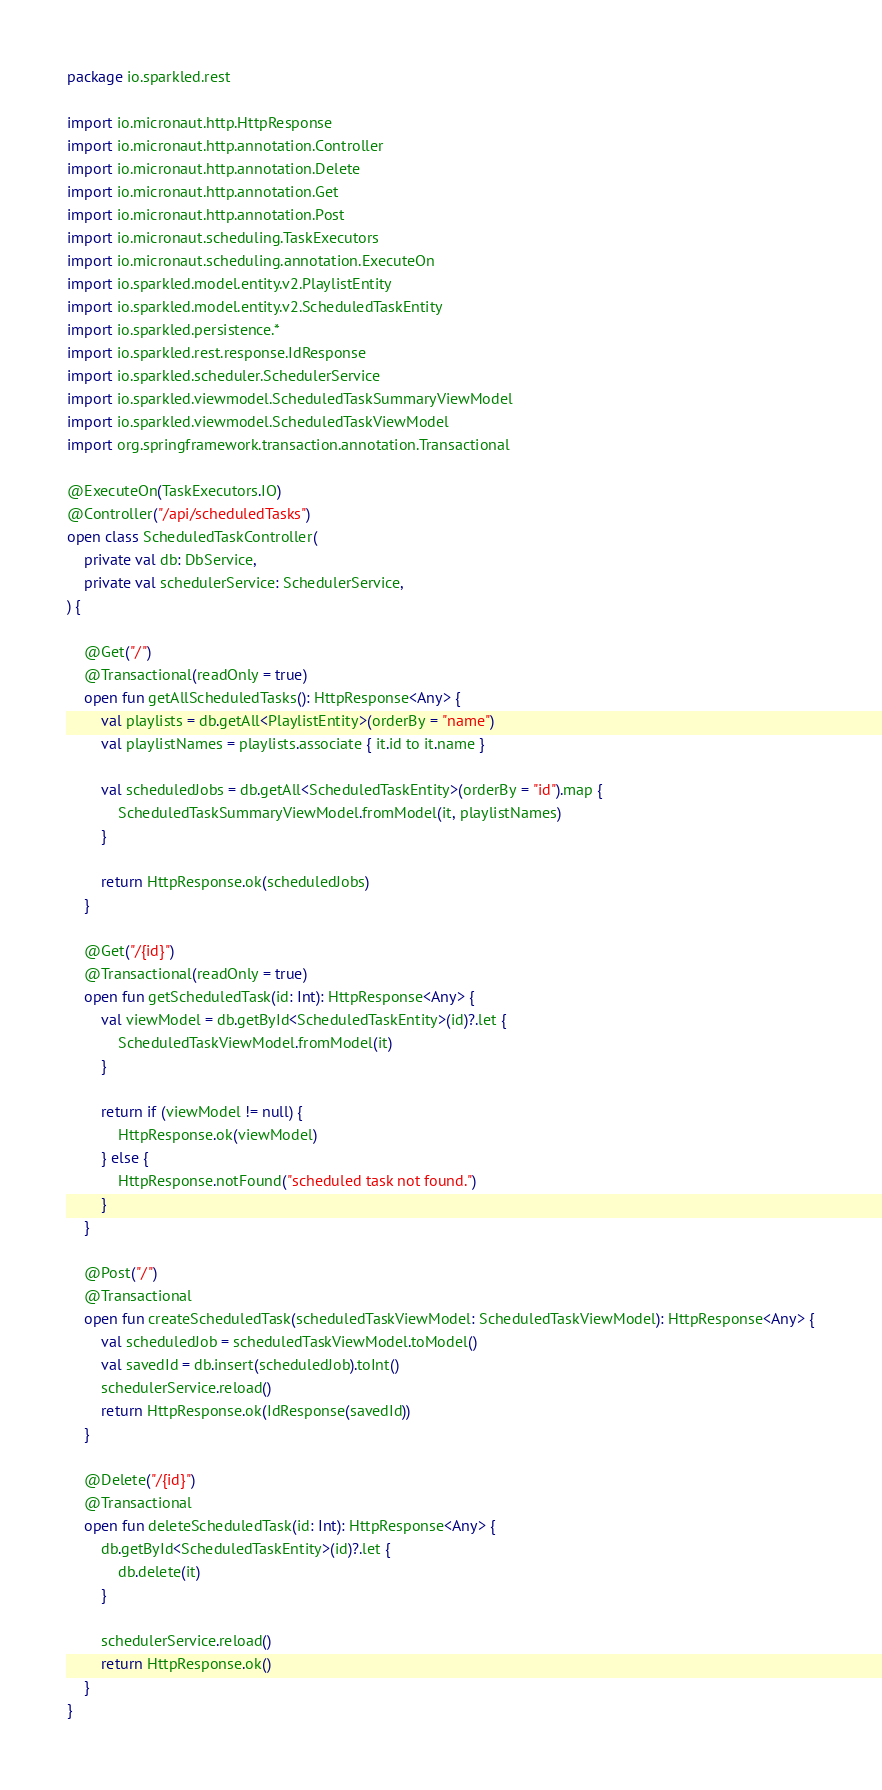<code> <loc_0><loc_0><loc_500><loc_500><_Kotlin_>package io.sparkled.rest

import io.micronaut.http.HttpResponse
import io.micronaut.http.annotation.Controller
import io.micronaut.http.annotation.Delete
import io.micronaut.http.annotation.Get
import io.micronaut.http.annotation.Post
import io.micronaut.scheduling.TaskExecutors
import io.micronaut.scheduling.annotation.ExecuteOn
import io.sparkled.model.entity.v2.PlaylistEntity
import io.sparkled.model.entity.v2.ScheduledTaskEntity
import io.sparkled.persistence.*
import io.sparkled.rest.response.IdResponse
import io.sparkled.scheduler.SchedulerService
import io.sparkled.viewmodel.ScheduledTaskSummaryViewModel
import io.sparkled.viewmodel.ScheduledTaskViewModel
import org.springframework.transaction.annotation.Transactional

@ExecuteOn(TaskExecutors.IO)
@Controller("/api/scheduledTasks")
open class ScheduledTaskController(
    private val db: DbService,
    private val schedulerService: SchedulerService,
) {

    @Get("/")
    @Transactional(readOnly = true)
    open fun getAllScheduledTasks(): HttpResponse<Any> {
        val playlists = db.getAll<PlaylistEntity>(orderBy = "name")
        val playlistNames = playlists.associate { it.id to it.name }

        val scheduledJobs = db.getAll<ScheduledTaskEntity>(orderBy = "id").map {
            ScheduledTaskSummaryViewModel.fromModel(it, playlistNames)
        }

        return HttpResponse.ok(scheduledJobs)
    }

    @Get("/{id}")
    @Transactional(readOnly = true)
    open fun getScheduledTask(id: Int): HttpResponse<Any> {
        val viewModel = db.getById<ScheduledTaskEntity>(id)?.let {
            ScheduledTaskViewModel.fromModel(it)
        }

        return if (viewModel != null) {
            HttpResponse.ok(viewModel)
        } else {
            HttpResponse.notFound("scheduled task not found.")
        }
    }

    @Post("/")
    @Transactional
    open fun createScheduledTask(scheduledTaskViewModel: ScheduledTaskViewModel): HttpResponse<Any> {
        val scheduledJob = scheduledTaskViewModel.toModel()
        val savedId = db.insert(scheduledJob).toInt()
        schedulerService.reload()
        return HttpResponse.ok(IdResponse(savedId))
    }

    @Delete("/{id}")
    @Transactional
    open fun deleteScheduledTask(id: Int): HttpResponse<Any> {
        db.getById<ScheduledTaskEntity>(id)?.let {
            db.delete(it)
        }

        schedulerService.reload()
        return HttpResponse.ok()
    }
}
</code> 